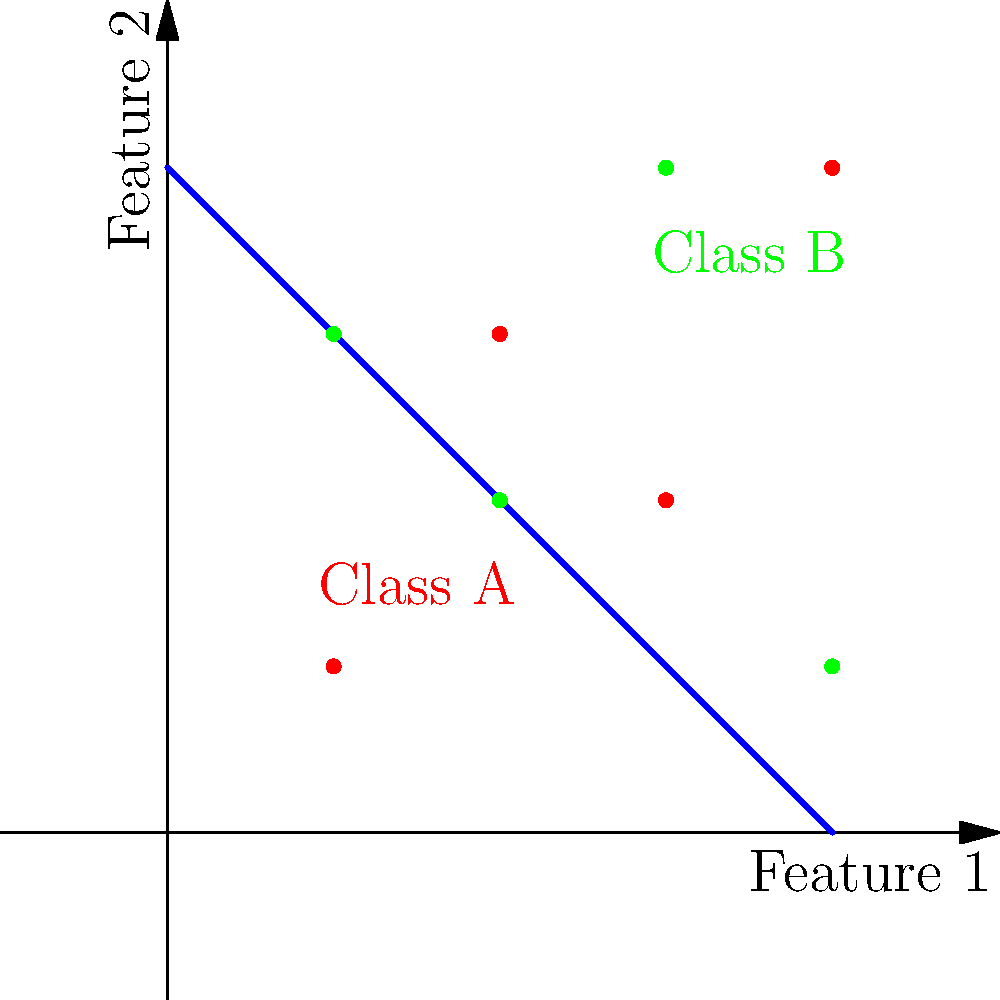Given the plot of a decision boundary for a neural network classifier in a 2D feature space, what can you infer about the model's performance and the separability of the two classes? How would you interpret the misclassified points, and what might this suggest about potential improvements to the model? To interpret the decision boundary and the model's performance, let's follow these steps:

1. Identify the classes:
   - Red dots represent Class A
   - Green dots represent Class B

2. Observe the decision boundary:
   - The blue line represents the decision boundary
   - It's a straight line, suggesting a linear separator between classes

3. Analyze the classification:
   - Points above and to the left of the boundary are classified as Class B
   - Points below and to the right of the boundary are classified as Class A

4. Evaluate the model's performance:
   - Most points are correctly classified (on the correct side of the boundary)
   - There are two misclassified points:
     a. One red point (Class A) above the boundary
     b. One green point (Class B) below the boundary

5. Interpret misclassifications:
   - These errors suggest that the classes are not perfectly linearly separable
   - The model's current linear boundary cannot capture all the complexity in the data

6. Consider potential improvements:
   - A non-linear decision boundary might perform better
   - This could be achieved by:
     a. Adding more layers to the neural network
     b. Introducing non-linear activation functions
     c. Using a different type of model (e.g., SVM with non-linear kernel)

7. Assess overall separability:
   - Despite some overlap, the classes appear generally separable
   - A more complex model might achieve better separation

8. Evaluate model confidence:
   - Points further from the decision boundary are likely classified with higher confidence
   - Points closer to the boundary have a higher risk of misclassification

In summary, the model shows good performance with a simple linear boundary, but there's room for improvement to handle the non-linear aspects of the data distribution.
Answer: The model performs well with a linear boundary, but misclassifications suggest non-linear separability. Improvements could include adding complexity to the neural network or using non-linear models. 